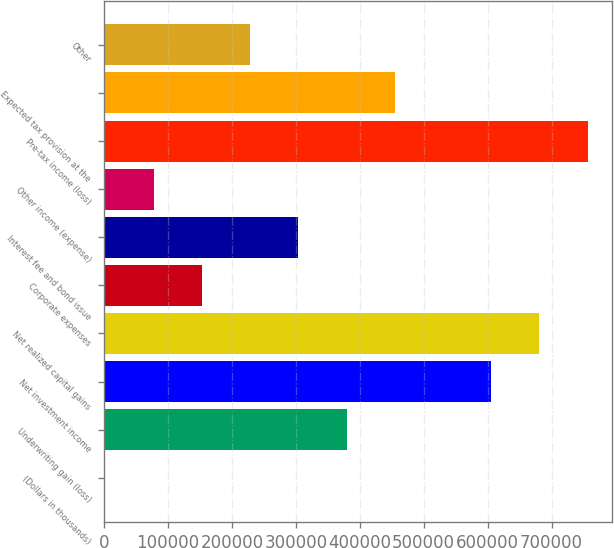Convert chart to OTSL. <chart><loc_0><loc_0><loc_500><loc_500><bar_chart><fcel>(Dollars in thousands)<fcel>Underwriting gain (loss)<fcel>Net investment income<fcel>Net realized capital gains<fcel>Corporate expenses<fcel>Interest fee and bond issue<fcel>Other income (expense)<fcel>Pre-tax income (loss)<fcel>Expected tax provision at the<fcel>Other<nl><fcel>2013<fcel>379323<fcel>605709<fcel>681171<fcel>152937<fcel>303861<fcel>77475<fcel>756633<fcel>454785<fcel>228399<nl></chart> 